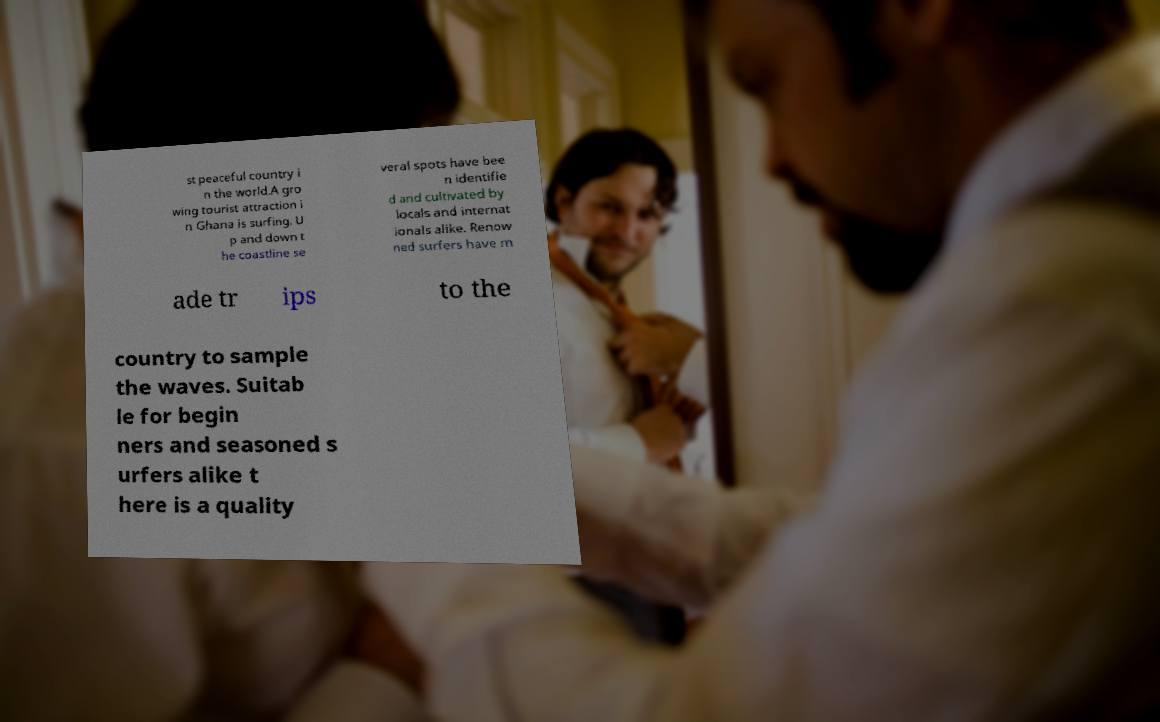What messages or text are displayed in this image? I need them in a readable, typed format. st peaceful country i n the world.A gro wing tourist attraction i n Ghana is surfing. U p and down t he coastline se veral spots have bee n identifie d and cultivated by locals and internat ionals alike. Renow ned surfers have m ade tr ips to the country to sample the waves. Suitab le for begin ners and seasoned s urfers alike t here is a quality 